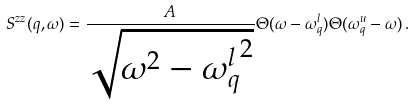<formula> <loc_0><loc_0><loc_500><loc_500>S ^ { z z } ( q , \omega ) = \frac { A } { \sqrt { \omega ^ { 2 } - { \omega ^ { l } _ { q } } ^ { 2 } } } \Theta ( \omega - \omega ^ { l } _ { q } ) \Theta ( \omega ^ { u } _ { q } - \omega ) \, .</formula> 